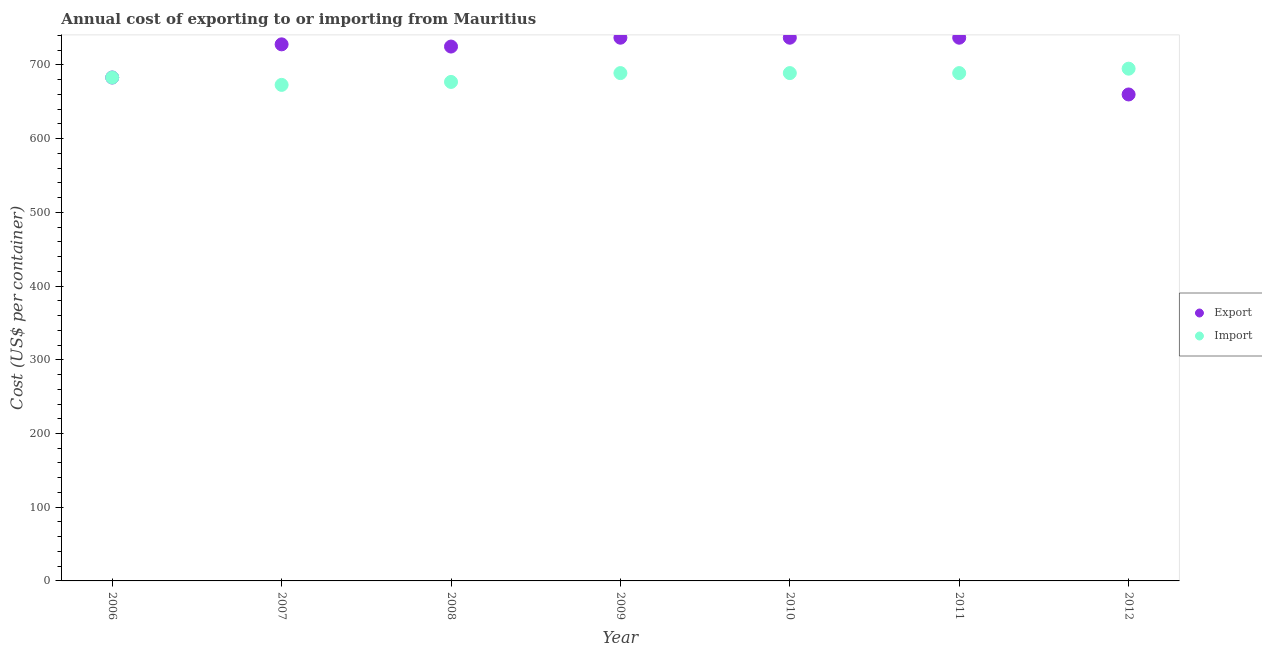How many different coloured dotlines are there?
Your response must be concise. 2. Is the number of dotlines equal to the number of legend labels?
Keep it short and to the point. Yes. What is the export cost in 2007?
Keep it short and to the point. 728. Across all years, what is the maximum export cost?
Make the answer very short. 737. Across all years, what is the minimum export cost?
Ensure brevity in your answer.  660. In which year was the export cost maximum?
Provide a succinct answer. 2009. What is the total import cost in the graph?
Your answer should be very brief. 4795. What is the difference between the export cost in 2007 and that in 2008?
Your response must be concise. 3. What is the difference between the export cost in 2007 and the import cost in 2006?
Your answer should be very brief. 45. What is the average export cost per year?
Ensure brevity in your answer.  715.29. In the year 2009, what is the difference between the import cost and export cost?
Ensure brevity in your answer.  -48. In how many years, is the import cost greater than 60 US$?
Ensure brevity in your answer.  7. What is the ratio of the export cost in 2007 to that in 2010?
Offer a very short reply. 0.99. Is the import cost in 2007 less than that in 2012?
Provide a short and direct response. Yes. Is the difference between the export cost in 2008 and 2009 greater than the difference between the import cost in 2008 and 2009?
Offer a very short reply. No. What is the difference between the highest and the second highest import cost?
Offer a very short reply. 6. What is the difference between the highest and the lowest import cost?
Provide a short and direct response. 22. Is the sum of the export cost in 2006 and 2010 greater than the maximum import cost across all years?
Ensure brevity in your answer.  Yes. What is the difference between two consecutive major ticks on the Y-axis?
Provide a succinct answer. 100. Are the values on the major ticks of Y-axis written in scientific E-notation?
Your answer should be very brief. No. How many legend labels are there?
Offer a terse response. 2. How are the legend labels stacked?
Ensure brevity in your answer.  Vertical. What is the title of the graph?
Ensure brevity in your answer.  Annual cost of exporting to or importing from Mauritius. Does "Passenger Transport Items" appear as one of the legend labels in the graph?
Offer a terse response. No. What is the label or title of the Y-axis?
Offer a very short reply. Cost (US$ per container). What is the Cost (US$ per container) of Export in 2006?
Keep it short and to the point. 683. What is the Cost (US$ per container) in Import in 2006?
Your answer should be very brief. 683. What is the Cost (US$ per container) of Export in 2007?
Give a very brief answer. 728. What is the Cost (US$ per container) of Import in 2007?
Provide a succinct answer. 673. What is the Cost (US$ per container) of Export in 2008?
Ensure brevity in your answer.  725. What is the Cost (US$ per container) in Import in 2008?
Your response must be concise. 677. What is the Cost (US$ per container) in Export in 2009?
Your answer should be compact. 737. What is the Cost (US$ per container) of Import in 2009?
Your answer should be very brief. 689. What is the Cost (US$ per container) in Export in 2010?
Your response must be concise. 737. What is the Cost (US$ per container) in Import in 2010?
Provide a short and direct response. 689. What is the Cost (US$ per container) of Export in 2011?
Keep it short and to the point. 737. What is the Cost (US$ per container) in Import in 2011?
Your answer should be very brief. 689. What is the Cost (US$ per container) in Export in 2012?
Provide a succinct answer. 660. What is the Cost (US$ per container) in Import in 2012?
Keep it short and to the point. 695. Across all years, what is the maximum Cost (US$ per container) of Export?
Make the answer very short. 737. Across all years, what is the maximum Cost (US$ per container) in Import?
Provide a short and direct response. 695. Across all years, what is the minimum Cost (US$ per container) in Export?
Ensure brevity in your answer.  660. Across all years, what is the minimum Cost (US$ per container) in Import?
Your response must be concise. 673. What is the total Cost (US$ per container) of Export in the graph?
Offer a very short reply. 5007. What is the total Cost (US$ per container) in Import in the graph?
Ensure brevity in your answer.  4795. What is the difference between the Cost (US$ per container) of Export in 2006 and that in 2007?
Your answer should be compact. -45. What is the difference between the Cost (US$ per container) of Import in 2006 and that in 2007?
Ensure brevity in your answer.  10. What is the difference between the Cost (US$ per container) in Export in 2006 and that in 2008?
Provide a succinct answer. -42. What is the difference between the Cost (US$ per container) of Export in 2006 and that in 2009?
Your answer should be compact. -54. What is the difference between the Cost (US$ per container) in Export in 2006 and that in 2010?
Your answer should be compact. -54. What is the difference between the Cost (US$ per container) of Import in 2006 and that in 2010?
Your response must be concise. -6. What is the difference between the Cost (US$ per container) of Export in 2006 and that in 2011?
Offer a very short reply. -54. What is the difference between the Cost (US$ per container) in Import in 2006 and that in 2011?
Keep it short and to the point. -6. What is the difference between the Cost (US$ per container) in Import in 2007 and that in 2008?
Provide a succinct answer. -4. What is the difference between the Cost (US$ per container) in Import in 2007 and that in 2009?
Offer a very short reply. -16. What is the difference between the Cost (US$ per container) in Export in 2007 and that in 2010?
Provide a succinct answer. -9. What is the difference between the Cost (US$ per container) of Import in 2007 and that in 2010?
Your response must be concise. -16. What is the difference between the Cost (US$ per container) of Export in 2007 and that in 2012?
Offer a terse response. 68. What is the difference between the Cost (US$ per container) of Import in 2007 and that in 2012?
Keep it short and to the point. -22. What is the difference between the Cost (US$ per container) of Export in 2008 and that in 2009?
Offer a very short reply. -12. What is the difference between the Cost (US$ per container) of Export in 2008 and that in 2010?
Your answer should be very brief. -12. What is the difference between the Cost (US$ per container) of Export in 2008 and that in 2012?
Provide a short and direct response. 65. What is the difference between the Cost (US$ per container) of Export in 2009 and that in 2011?
Give a very brief answer. 0. What is the difference between the Cost (US$ per container) in Export in 2009 and that in 2012?
Your response must be concise. 77. What is the difference between the Cost (US$ per container) in Export in 2010 and that in 2011?
Your answer should be very brief. 0. What is the difference between the Cost (US$ per container) in Export in 2010 and that in 2012?
Give a very brief answer. 77. What is the difference between the Cost (US$ per container) of Export in 2011 and that in 2012?
Ensure brevity in your answer.  77. What is the difference between the Cost (US$ per container) in Export in 2006 and the Cost (US$ per container) in Import in 2007?
Make the answer very short. 10. What is the difference between the Cost (US$ per container) of Export in 2006 and the Cost (US$ per container) of Import in 2009?
Provide a succinct answer. -6. What is the difference between the Cost (US$ per container) in Export in 2007 and the Cost (US$ per container) in Import in 2008?
Keep it short and to the point. 51. What is the difference between the Cost (US$ per container) of Export in 2007 and the Cost (US$ per container) of Import in 2009?
Your answer should be very brief. 39. What is the difference between the Cost (US$ per container) in Export in 2007 and the Cost (US$ per container) in Import in 2011?
Your answer should be compact. 39. What is the difference between the Cost (US$ per container) in Export in 2007 and the Cost (US$ per container) in Import in 2012?
Give a very brief answer. 33. What is the difference between the Cost (US$ per container) of Export in 2009 and the Cost (US$ per container) of Import in 2010?
Provide a short and direct response. 48. What is the difference between the Cost (US$ per container) of Export in 2009 and the Cost (US$ per container) of Import in 2011?
Your answer should be very brief. 48. What is the difference between the Cost (US$ per container) of Export in 2009 and the Cost (US$ per container) of Import in 2012?
Give a very brief answer. 42. What is the difference between the Cost (US$ per container) in Export in 2010 and the Cost (US$ per container) in Import in 2011?
Ensure brevity in your answer.  48. What is the difference between the Cost (US$ per container) in Export in 2010 and the Cost (US$ per container) in Import in 2012?
Keep it short and to the point. 42. What is the difference between the Cost (US$ per container) in Export in 2011 and the Cost (US$ per container) in Import in 2012?
Give a very brief answer. 42. What is the average Cost (US$ per container) of Export per year?
Give a very brief answer. 715.29. What is the average Cost (US$ per container) of Import per year?
Your answer should be compact. 685. In the year 2006, what is the difference between the Cost (US$ per container) of Export and Cost (US$ per container) of Import?
Offer a terse response. 0. In the year 2008, what is the difference between the Cost (US$ per container) in Export and Cost (US$ per container) in Import?
Your answer should be very brief. 48. In the year 2012, what is the difference between the Cost (US$ per container) in Export and Cost (US$ per container) in Import?
Offer a very short reply. -35. What is the ratio of the Cost (US$ per container) in Export in 2006 to that in 2007?
Your answer should be very brief. 0.94. What is the ratio of the Cost (US$ per container) in Import in 2006 to that in 2007?
Give a very brief answer. 1.01. What is the ratio of the Cost (US$ per container) of Export in 2006 to that in 2008?
Your response must be concise. 0.94. What is the ratio of the Cost (US$ per container) in Import in 2006 to that in 2008?
Make the answer very short. 1.01. What is the ratio of the Cost (US$ per container) of Export in 2006 to that in 2009?
Make the answer very short. 0.93. What is the ratio of the Cost (US$ per container) of Export in 2006 to that in 2010?
Provide a short and direct response. 0.93. What is the ratio of the Cost (US$ per container) of Import in 2006 to that in 2010?
Give a very brief answer. 0.99. What is the ratio of the Cost (US$ per container) of Export in 2006 to that in 2011?
Give a very brief answer. 0.93. What is the ratio of the Cost (US$ per container) in Import in 2006 to that in 2011?
Offer a very short reply. 0.99. What is the ratio of the Cost (US$ per container) of Export in 2006 to that in 2012?
Give a very brief answer. 1.03. What is the ratio of the Cost (US$ per container) in Import in 2006 to that in 2012?
Your response must be concise. 0.98. What is the ratio of the Cost (US$ per container) in Export in 2007 to that in 2008?
Your response must be concise. 1. What is the ratio of the Cost (US$ per container) of Export in 2007 to that in 2009?
Provide a short and direct response. 0.99. What is the ratio of the Cost (US$ per container) of Import in 2007 to that in 2009?
Offer a very short reply. 0.98. What is the ratio of the Cost (US$ per container) of Import in 2007 to that in 2010?
Your response must be concise. 0.98. What is the ratio of the Cost (US$ per container) of Import in 2007 to that in 2011?
Your answer should be very brief. 0.98. What is the ratio of the Cost (US$ per container) in Export in 2007 to that in 2012?
Offer a very short reply. 1.1. What is the ratio of the Cost (US$ per container) in Import in 2007 to that in 2012?
Give a very brief answer. 0.97. What is the ratio of the Cost (US$ per container) in Export in 2008 to that in 2009?
Offer a terse response. 0.98. What is the ratio of the Cost (US$ per container) in Import in 2008 to that in 2009?
Your answer should be compact. 0.98. What is the ratio of the Cost (US$ per container) of Export in 2008 to that in 2010?
Your response must be concise. 0.98. What is the ratio of the Cost (US$ per container) of Import in 2008 to that in 2010?
Keep it short and to the point. 0.98. What is the ratio of the Cost (US$ per container) in Export in 2008 to that in 2011?
Ensure brevity in your answer.  0.98. What is the ratio of the Cost (US$ per container) in Import in 2008 to that in 2011?
Provide a succinct answer. 0.98. What is the ratio of the Cost (US$ per container) in Export in 2008 to that in 2012?
Provide a succinct answer. 1.1. What is the ratio of the Cost (US$ per container) of Import in 2008 to that in 2012?
Provide a succinct answer. 0.97. What is the ratio of the Cost (US$ per container) in Export in 2009 to that in 2010?
Provide a short and direct response. 1. What is the ratio of the Cost (US$ per container) in Import in 2009 to that in 2010?
Offer a terse response. 1. What is the ratio of the Cost (US$ per container) in Export in 2009 to that in 2011?
Your answer should be compact. 1. What is the ratio of the Cost (US$ per container) of Export in 2009 to that in 2012?
Your answer should be compact. 1.12. What is the ratio of the Cost (US$ per container) in Export in 2010 to that in 2011?
Your response must be concise. 1. What is the ratio of the Cost (US$ per container) in Export in 2010 to that in 2012?
Keep it short and to the point. 1.12. What is the ratio of the Cost (US$ per container) of Export in 2011 to that in 2012?
Provide a succinct answer. 1.12. What is the ratio of the Cost (US$ per container) in Import in 2011 to that in 2012?
Ensure brevity in your answer.  0.99. What is the difference between the highest and the second highest Cost (US$ per container) in Export?
Your response must be concise. 0. What is the difference between the highest and the lowest Cost (US$ per container) in Export?
Give a very brief answer. 77. What is the difference between the highest and the lowest Cost (US$ per container) in Import?
Keep it short and to the point. 22. 